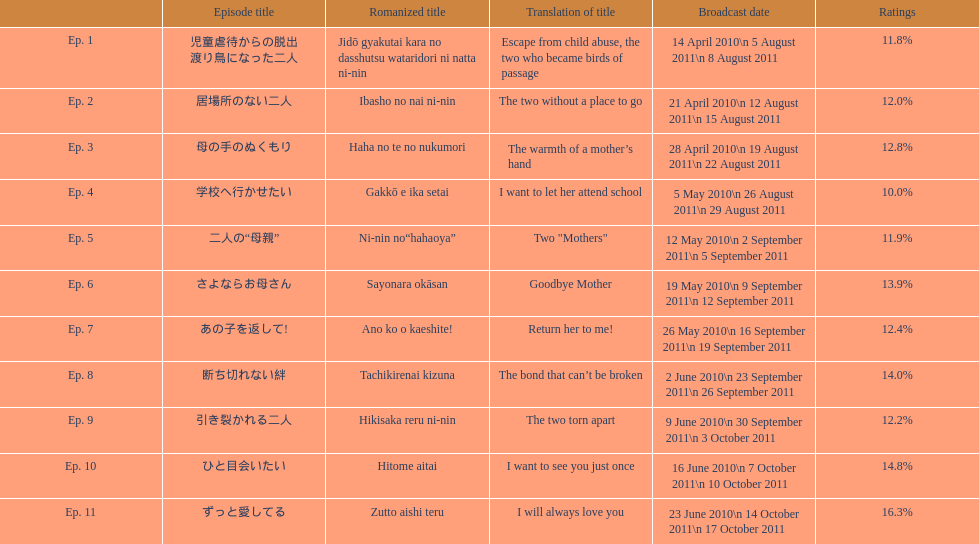What was the name of the next episode after goodbye mother? あの子を返して!. 